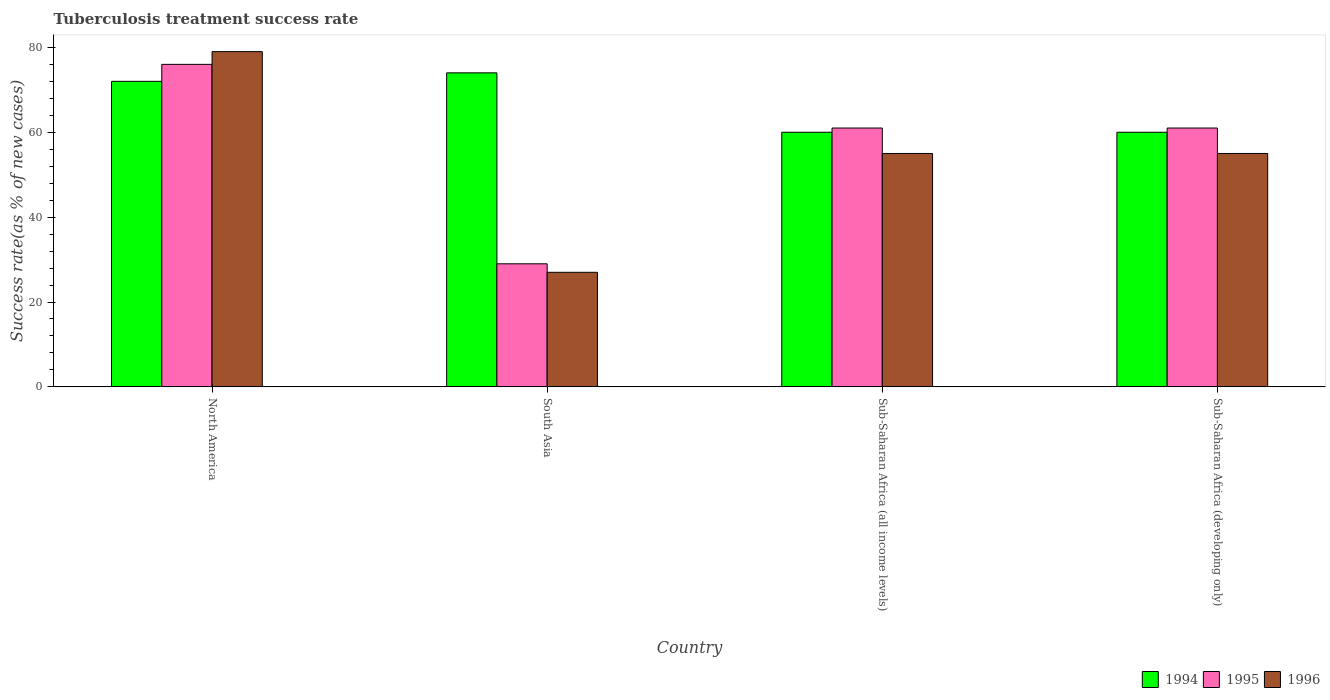How many different coloured bars are there?
Make the answer very short. 3. How many bars are there on the 2nd tick from the right?
Offer a terse response. 3. Across all countries, what is the minimum tuberculosis treatment success rate in 1996?
Offer a very short reply. 27. In which country was the tuberculosis treatment success rate in 1996 maximum?
Give a very brief answer. North America. What is the total tuberculosis treatment success rate in 1994 in the graph?
Offer a terse response. 266. What is the difference between the tuberculosis treatment success rate in 1994 in Sub-Saharan Africa (developing only) and the tuberculosis treatment success rate in 1996 in North America?
Make the answer very short. -19. What is the average tuberculosis treatment success rate in 1994 per country?
Keep it short and to the point. 66.5. What is the ratio of the tuberculosis treatment success rate in 1995 in North America to that in Sub-Saharan Africa (all income levels)?
Provide a succinct answer. 1.25. Is the tuberculosis treatment success rate in 1995 in South Asia less than that in Sub-Saharan Africa (developing only)?
Your response must be concise. Yes. Is the difference between the tuberculosis treatment success rate in 1996 in North America and Sub-Saharan Africa (developing only) greater than the difference between the tuberculosis treatment success rate in 1995 in North America and Sub-Saharan Africa (developing only)?
Keep it short and to the point. Yes. What is the difference between the highest and the second highest tuberculosis treatment success rate in 1996?
Offer a terse response. -24. What is the difference between the highest and the lowest tuberculosis treatment success rate in 1994?
Give a very brief answer. 14. Is the sum of the tuberculosis treatment success rate in 1995 in North America and Sub-Saharan Africa (all income levels) greater than the maximum tuberculosis treatment success rate in 1994 across all countries?
Offer a very short reply. Yes. What does the 3rd bar from the left in South Asia represents?
Your response must be concise. 1996. What does the 3rd bar from the right in Sub-Saharan Africa (developing only) represents?
Give a very brief answer. 1994. What is the difference between two consecutive major ticks on the Y-axis?
Make the answer very short. 20. Does the graph contain grids?
Make the answer very short. No. How many legend labels are there?
Make the answer very short. 3. How are the legend labels stacked?
Your response must be concise. Horizontal. What is the title of the graph?
Your answer should be very brief. Tuberculosis treatment success rate. What is the label or title of the Y-axis?
Your response must be concise. Success rate(as % of new cases). What is the Success rate(as % of new cases) of 1994 in North America?
Give a very brief answer. 72. What is the Success rate(as % of new cases) in 1995 in North America?
Your response must be concise. 76. What is the Success rate(as % of new cases) of 1996 in North America?
Your answer should be compact. 79. What is the Success rate(as % of new cases) in 1995 in South Asia?
Offer a very short reply. 29. What is the Success rate(as % of new cases) of 1994 in Sub-Saharan Africa (all income levels)?
Your response must be concise. 60. What is the Success rate(as % of new cases) in 1996 in Sub-Saharan Africa (all income levels)?
Give a very brief answer. 55. What is the Success rate(as % of new cases) of 1995 in Sub-Saharan Africa (developing only)?
Give a very brief answer. 61. What is the Success rate(as % of new cases) in 1996 in Sub-Saharan Africa (developing only)?
Provide a succinct answer. 55. Across all countries, what is the maximum Success rate(as % of new cases) of 1994?
Your answer should be compact. 74. Across all countries, what is the maximum Success rate(as % of new cases) of 1995?
Provide a succinct answer. 76. Across all countries, what is the maximum Success rate(as % of new cases) in 1996?
Keep it short and to the point. 79. Across all countries, what is the minimum Success rate(as % of new cases) of 1995?
Your answer should be very brief. 29. Across all countries, what is the minimum Success rate(as % of new cases) in 1996?
Your response must be concise. 27. What is the total Success rate(as % of new cases) in 1994 in the graph?
Make the answer very short. 266. What is the total Success rate(as % of new cases) of 1995 in the graph?
Make the answer very short. 227. What is the total Success rate(as % of new cases) of 1996 in the graph?
Provide a succinct answer. 216. What is the difference between the Success rate(as % of new cases) in 1995 in North America and that in Sub-Saharan Africa (all income levels)?
Provide a succinct answer. 15. What is the difference between the Success rate(as % of new cases) in 1996 in North America and that in Sub-Saharan Africa (all income levels)?
Give a very brief answer. 24. What is the difference between the Success rate(as % of new cases) of 1994 in North America and that in Sub-Saharan Africa (developing only)?
Your response must be concise. 12. What is the difference between the Success rate(as % of new cases) in 1994 in South Asia and that in Sub-Saharan Africa (all income levels)?
Keep it short and to the point. 14. What is the difference between the Success rate(as % of new cases) of 1995 in South Asia and that in Sub-Saharan Africa (all income levels)?
Provide a succinct answer. -32. What is the difference between the Success rate(as % of new cases) in 1996 in South Asia and that in Sub-Saharan Africa (all income levels)?
Provide a succinct answer. -28. What is the difference between the Success rate(as % of new cases) in 1995 in South Asia and that in Sub-Saharan Africa (developing only)?
Give a very brief answer. -32. What is the difference between the Success rate(as % of new cases) of 1996 in South Asia and that in Sub-Saharan Africa (developing only)?
Provide a succinct answer. -28. What is the difference between the Success rate(as % of new cases) in 1994 in Sub-Saharan Africa (all income levels) and that in Sub-Saharan Africa (developing only)?
Make the answer very short. 0. What is the difference between the Success rate(as % of new cases) of 1994 in North America and the Success rate(as % of new cases) of 1996 in South Asia?
Offer a very short reply. 45. What is the difference between the Success rate(as % of new cases) of 1995 in North America and the Success rate(as % of new cases) of 1996 in South Asia?
Provide a succinct answer. 49. What is the difference between the Success rate(as % of new cases) in 1994 in North America and the Success rate(as % of new cases) in 1995 in Sub-Saharan Africa (all income levels)?
Provide a short and direct response. 11. What is the difference between the Success rate(as % of new cases) in 1995 in North America and the Success rate(as % of new cases) in 1996 in Sub-Saharan Africa (all income levels)?
Keep it short and to the point. 21. What is the difference between the Success rate(as % of new cases) in 1994 in North America and the Success rate(as % of new cases) in 1995 in Sub-Saharan Africa (developing only)?
Offer a very short reply. 11. What is the difference between the Success rate(as % of new cases) of 1994 in North America and the Success rate(as % of new cases) of 1996 in Sub-Saharan Africa (developing only)?
Ensure brevity in your answer.  17. What is the difference between the Success rate(as % of new cases) in 1995 in North America and the Success rate(as % of new cases) in 1996 in Sub-Saharan Africa (developing only)?
Make the answer very short. 21. What is the difference between the Success rate(as % of new cases) of 1995 in South Asia and the Success rate(as % of new cases) of 1996 in Sub-Saharan Africa (all income levels)?
Your response must be concise. -26. What is the difference between the Success rate(as % of new cases) in 1994 in South Asia and the Success rate(as % of new cases) in 1995 in Sub-Saharan Africa (developing only)?
Provide a short and direct response. 13. What is the difference between the Success rate(as % of new cases) of 1995 in South Asia and the Success rate(as % of new cases) of 1996 in Sub-Saharan Africa (developing only)?
Ensure brevity in your answer.  -26. What is the difference between the Success rate(as % of new cases) in 1994 in Sub-Saharan Africa (all income levels) and the Success rate(as % of new cases) in 1995 in Sub-Saharan Africa (developing only)?
Your answer should be very brief. -1. What is the average Success rate(as % of new cases) in 1994 per country?
Give a very brief answer. 66.5. What is the average Success rate(as % of new cases) of 1995 per country?
Your answer should be compact. 56.75. What is the difference between the Success rate(as % of new cases) of 1995 and Success rate(as % of new cases) of 1996 in North America?
Make the answer very short. -3. What is the difference between the Success rate(as % of new cases) of 1994 and Success rate(as % of new cases) of 1995 in South Asia?
Provide a succinct answer. 45. What is the difference between the Success rate(as % of new cases) in 1994 and Success rate(as % of new cases) in 1996 in South Asia?
Make the answer very short. 47. What is the difference between the Success rate(as % of new cases) of 1994 and Success rate(as % of new cases) of 1995 in Sub-Saharan Africa (all income levels)?
Make the answer very short. -1. What is the difference between the Success rate(as % of new cases) in 1995 and Success rate(as % of new cases) in 1996 in Sub-Saharan Africa (all income levels)?
Ensure brevity in your answer.  6. What is the difference between the Success rate(as % of new cases) in 1995 and Success rate(as % of new cases) in 1996 in Sub-Saharan Africa (developing only)?
Your response must be concise. 6. What is the ratio of the Success rate(as % of new cases) of 1994 in North America to that in South Asia?
Offer a terse response. 0.97. What is the ratio of the Success rate(as % of new cases) in 1995 in North America to that in South Asia?
Your answer should be compact. 2.62. What is the ratio of the Success rate(as % of new cases) of 1996 in North America to that in South Asia?
Ensure brevity in your answer.  2.93. What is the ratio of the Success rate(as % of new cases) of 1995 in North America to that in Sub-Saharan Africa (all income levels)?
Offer a very short reply. 1.25. What is the ratio of the Success rate(as % of new cases) in 1996 in North America to that in Sub-Saharan Africa (all income levels)?
Offer a very short reply. 1.44. What is the ratio of the Success rate(as % of new cases) of 1995 in North America to that in Sub-Saharan Africa (developing only)?
Provide a succinct answer. 1.25. What is the ratio of the Success rate(as % of new cases) in 1996 in North America to that in Sub-Saharan Africa (developing only)?
Ensure brevity in your answer.  1.44. What is the ratio of the Success rate(as % of new cases) in 1994 in South Asia to that in Sub-Saharan Africa (all income levels)?
Provide a short and direct response. 1.23. What is the ratio of the Success rate(as % of new cases) in 1995 in South Asia to that in Sub-Saharan Africa (all income levels)?
Offer a very short reply. 0.48. What is the ratio of the Success rate(as % of new cases) of 1996 in South Asia to that in Sub-Saharan Africa (all income levels)?
Give a very brief answer. 0.49. What is the ratio of the Success rate(as % of new cases) of 1994 in South Asia to that in Sub-Saharan Africa (developing only)?
Make the answer very short. 1.23. What is the ratio of the Success rate(as % of new cases) of 1995 in South Asia to that in Sub-Saharan Africa (developing only)?
Offer a terse response. 0.48. What is the ratio of the Success rate(as % of new cases) of 1996 in South Asia to that in Sub-Saharan Africa (developing only)?
Provide a succinct answer. 0.49. What is the difference between the highest and the second highest Success rate(as % of new cases) in 1995?
Your answer should be compact. 15. What is the difference between the highest and the lowest Success rate(as % of new cases) of 1996?
Keep it short and to the point. 52. 